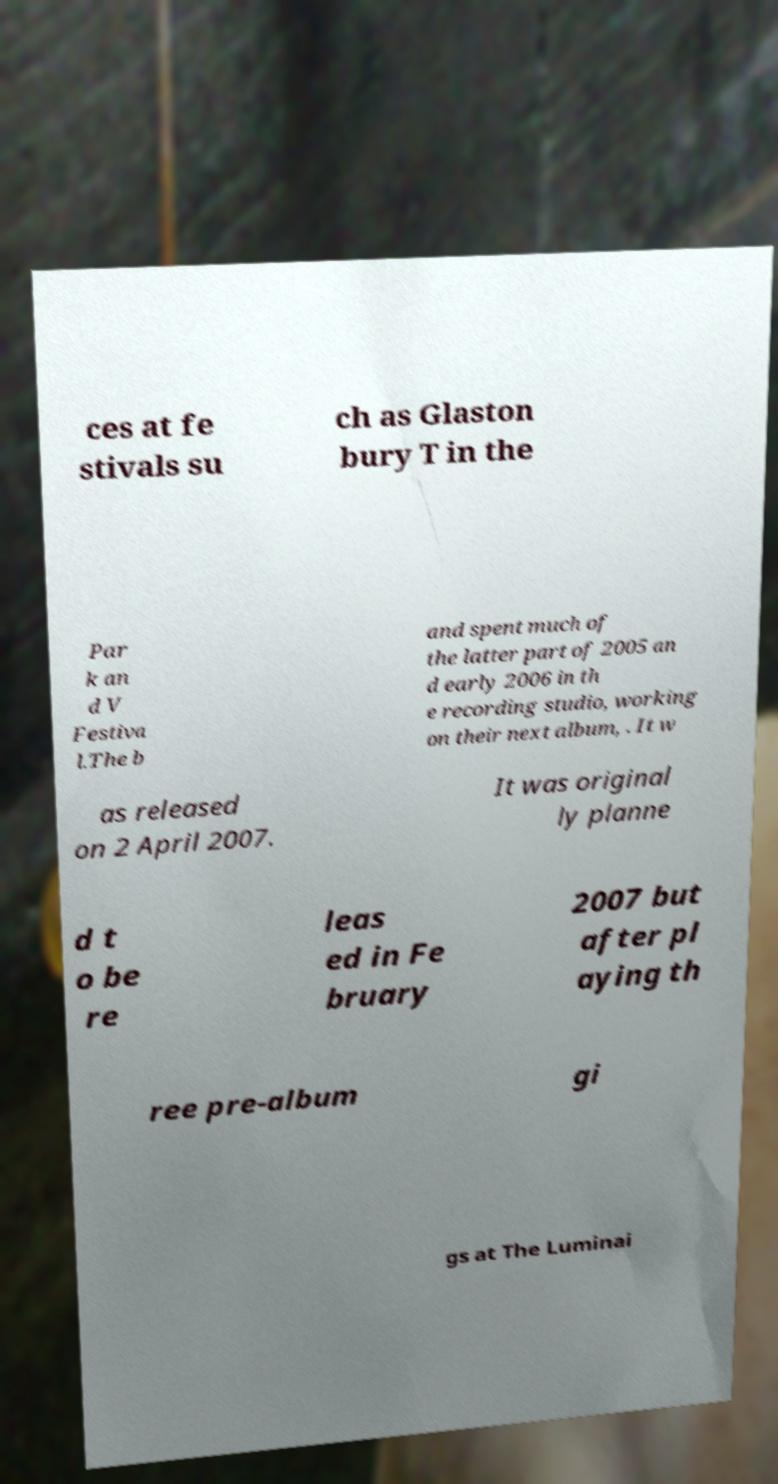Can you read and provide the text displayed in the image?This photo seems to have some interesting text. Can you extract and type it out for me? ces at fe stivals su ch as Glaston bury T in the Par k an d V Festiva l.The b and spent much of the latter part of 2005 an d early 2006 in th e recording studio, working on their next album, . It w as released on 2 April 2007. It was original ly planne d t o be re leas ed in Fe bruary 2007 but after pl aying th ree pre-album gi gs at The Luminai 